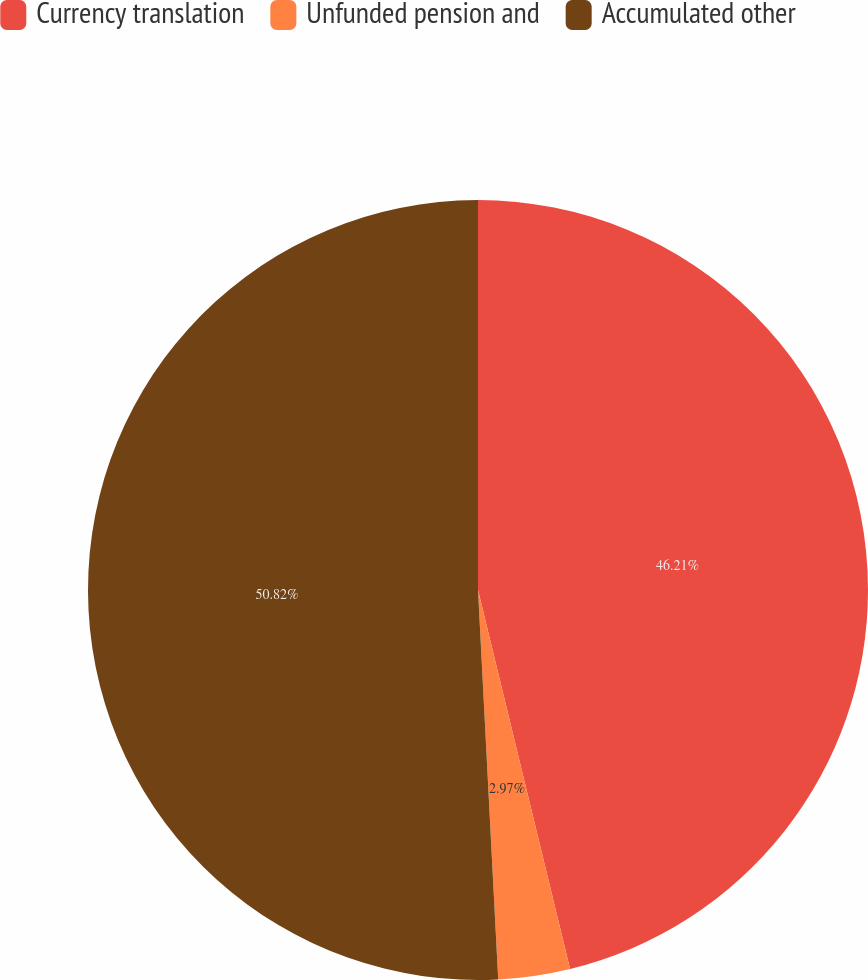Convert chart. <chart><loc_0><loc_0><loc_500><loc_500><pie_chart><fcel>Currency translation<fcel>Unfunded pension and<fcel>Accumulated other<nl><fcel>46.21%<fcel>2.97%<fcel>50.83%<nl></chart> 